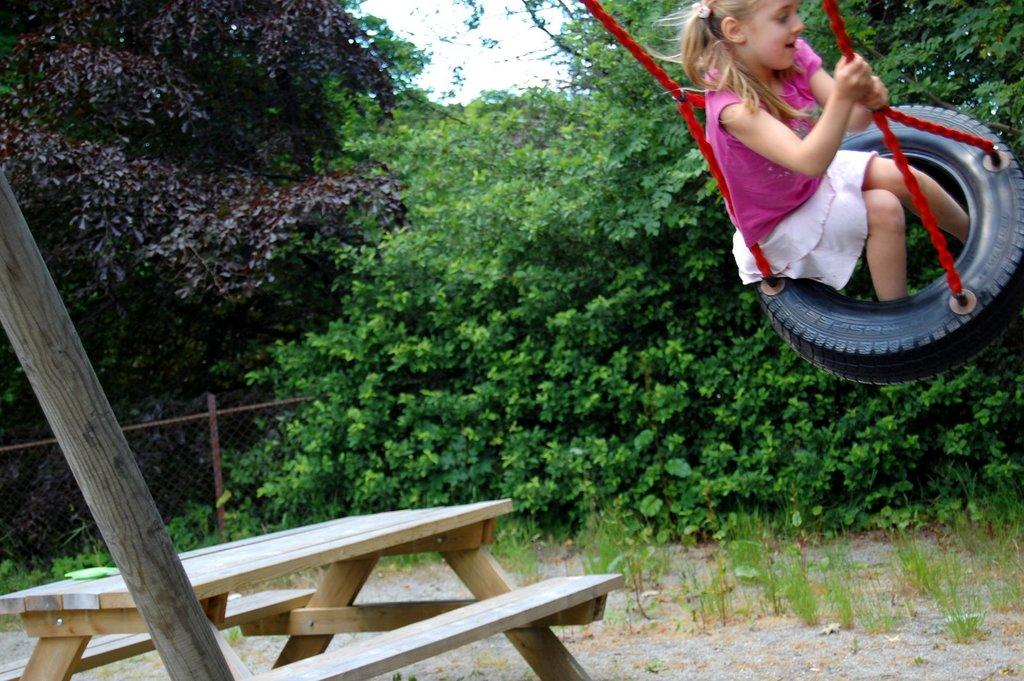Who is the main subject in the image? There is a girl in the image. What is the girl doing in the image? The girl is swinging on a tyre with ropes. What can be seen in the background of the image? There is a table, a bench, plants, and trees in the background of the image. What type of food is the girl eating while swinging on the tyre in the image? There is no food present in the image; the girl is swinging on a tyre with ropes. 